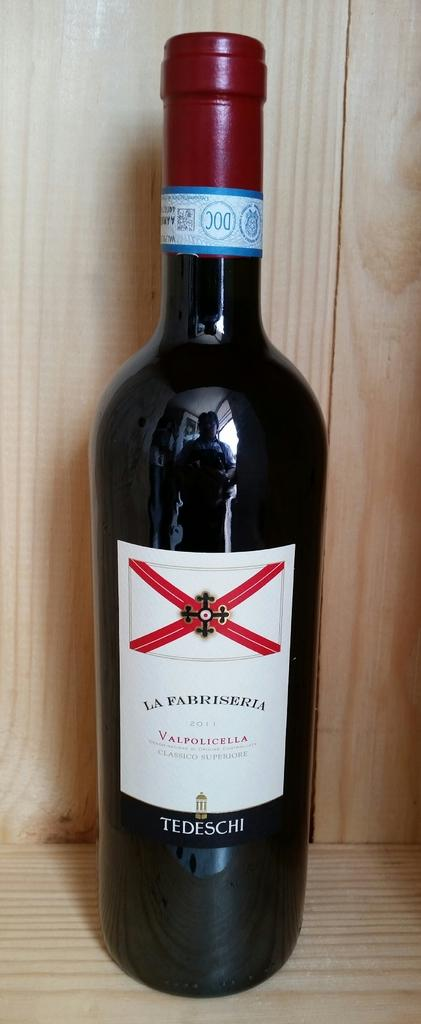<image>
Create a compact narrative representing the image presented. A bottle of La Fabriseria wine is from 2011. 